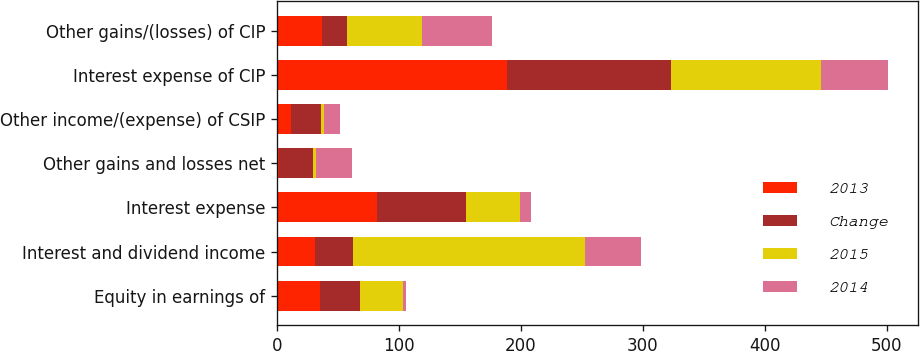<chart> <loc_0><loc_0><loc_500><loc_500><stacked_bar_chart><ecel><fcel>Equity in earnings of<fcel>Interest and dividend income<fcel>Interest expense<fcel>Other gains and losses net<fcel>Other income/(expense) of CSIP<fcel>Interest expense of CIP<fcel>Other gains/(losses) of CIP<nl><fcel>2013<fcel>35.1<fcel>31.2<fcel>81.7<fcel>1.5<fcel>11.7<fcel>188.9<fcel>37<nl><fcel>Change<fcel>32.8<fcel>31.2<fcel>73.1<fcel>28.1<fcel>24.3<fcel>133.9<fcel>20.4<nl><fcel>2015<fcel>35.5<fcel>190<fcel>44.6<fcel>2.6<fcel>2.9<fcel>123.3<fcel>61.9<nl><fcel>2014<fcel>2.3<fcel>46.5<fcel>8.6<fcel>29.6<fcel>12.6<fcel>55<fcel>57.4<nl></chart> 